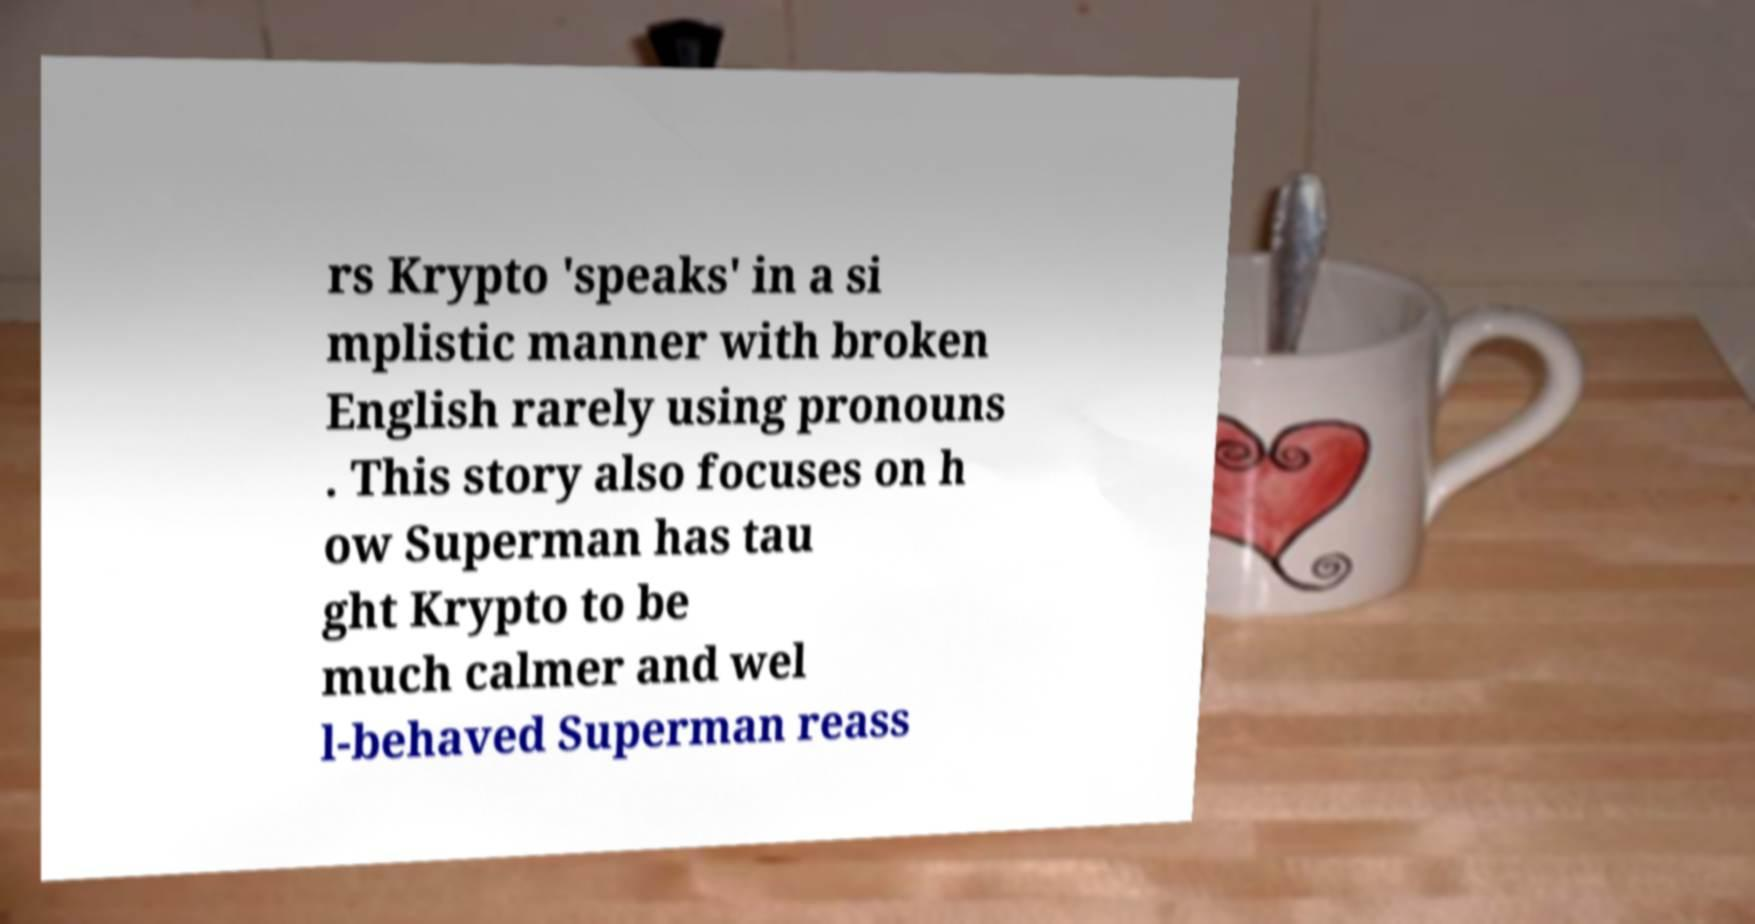Please identify and transcribe the text found in this image. rs Krypto 'speaks' in a si mplistic manner with broken English rarely using pronouns . This story also focuses on h ow Superman has tau ght Krypto to be much calmer and wel l-behaved Superman reass 